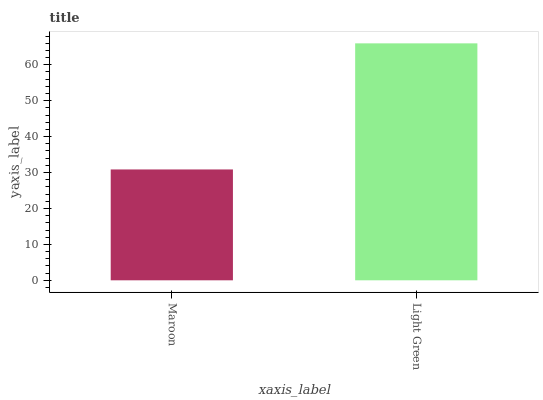Is Light Green the minimum?
Answer yes or no. No. Is Light Green greater than Maroon?
Answer yes or no. Yes. Is Maroon less than Light Green?
Answer yes or no. Yes. Is Maroon greater than Light Green?
Answer yes or no. No. Is Light Green less than Maroon?
Answer yes or no. No. Is Light Green the high median?
Answer yes or no. Yes. Is Maroon the low median?
Answer yes or no. Yes. Is Maroon the high median?
Answer yes or no. No. Is Light Green the low median?
Answer yes or no. No. 